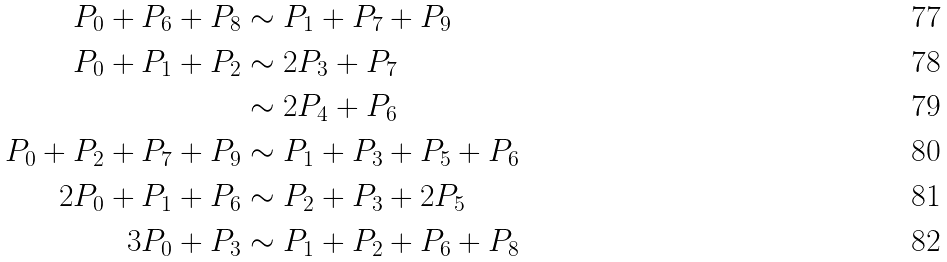<formula> <loc_0><loc_0><loc_500><loc_500>P _ { 0 } + P _ { 6 } + P _ { 8 } & \sim P _ { 1 } + P _ { 7 } + P _ { 9 } \\ P _ { 0 } + P _ { 1 } + P _ { 2 } & \sim 2 P _ { 3 } + P _ { 7 } \\ & \sim 2 P _ { 4 } + P _ { 6 } \\ P _ { 0 } + P _ { 2 } + P _ { 7 } + P _ { 9 } & \sim P _ { 1 } + P _ { 3 } + P _ { 5 } + P _ { 6 } \\ 2 P _ { 0 } + P _ { 1 } + P _ { 6 } & \sim P _ { 2 } + P _ { 3 } + 2 P _ { 5 } \\ 3 P _ { 0 } + P _ { 3 } & \sim P _ { 1 } + P _ { 2 } + P _ { 6 } + P _ { 8 }</formula> 